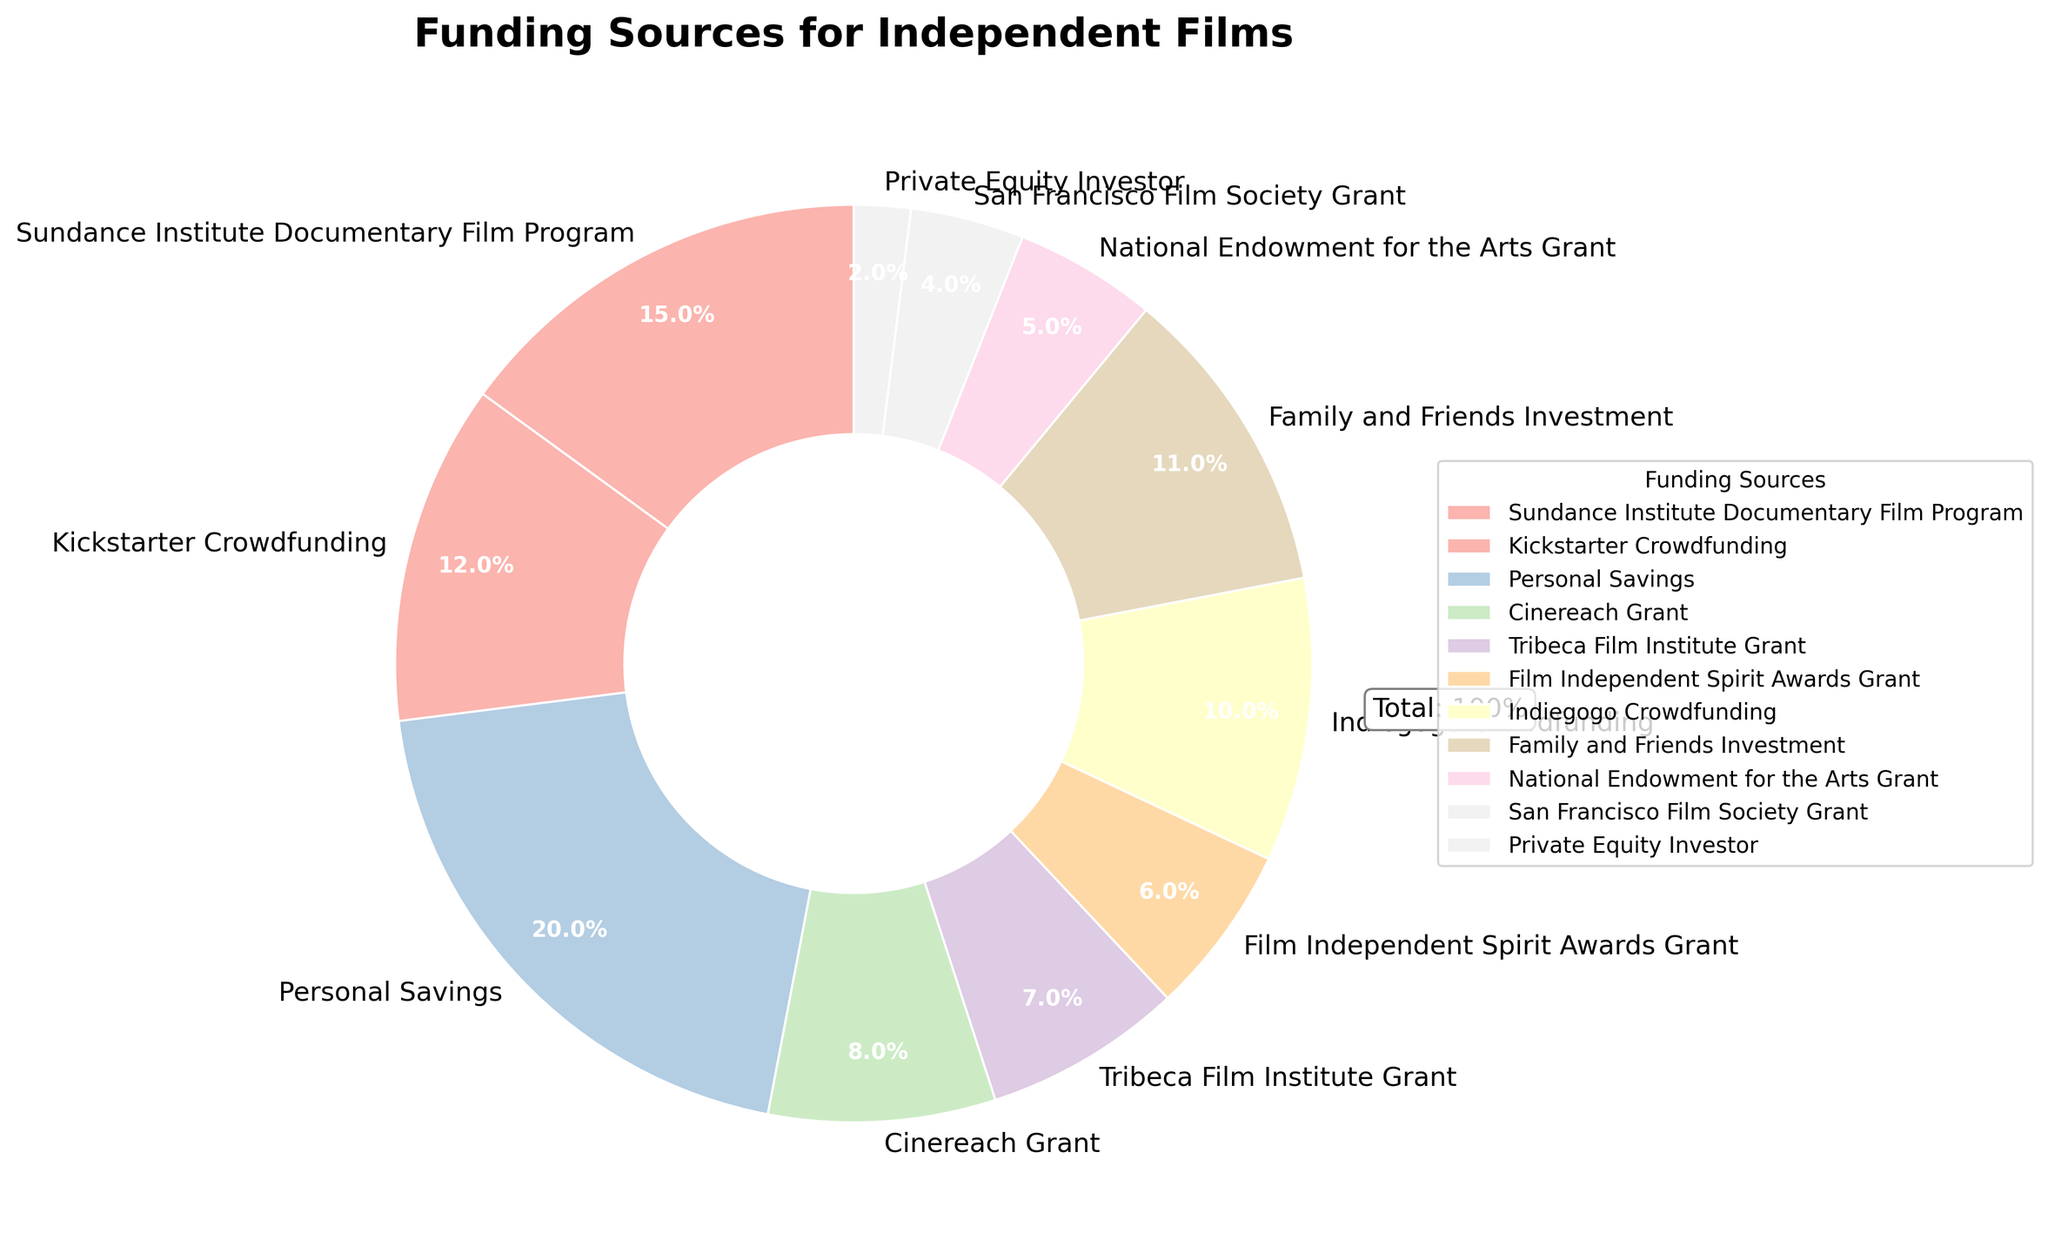Which funding source contributes the most to independent films? Personal Savings contributes 20%, which is the highest among all sources listed.
Answer: Personal Savings Which funding source contributes the second most to independent films? The Sundance Institute Documentary Film Program contributes 15%, second only to Personal Savings.
Answer: Sundance Institute Documentary Film Program How much more do Personal Savings contribute compared to Kickstarter Crowdfunding? Personal Savings contributes 20%, while Kickstarter Crowdfunding contributes 12%. The difference is 20% - 12% = 8%.
Answer: 8% Which two funding sources contribute equally to independent films? Both Indiegogo Crowdfunding and Family and Friends Investment contribute 10% and 11% respectively. There are no exact equal contributions among the sources listed.
Answer: None What is the combined contribution of all grants (not including crowdfunding or personal/family investments)? Summing up the contributions of all grants: Sundance Institute Documentary Film Program (15%), Cinereach Grant (8%), Tribeca Film Institute Grant (7%), Film Independent Spirit Awards Grant (6%), National Endowment for the Arts Grant (5%), San Francisco Film Society Grant (4%) gives 15% + 8% + 7% + 6% + 5% + 4% = 45%.
Answer: 45% Which crowdfunding platform contributes the least? Kickstarter Crowdfunding contributes 12% and Indiegogo Crowdfunding contributes 10%, so the least is Indiegogo Crowdfunding.
Answer: Indiegogo Crowdfunding Is the contribution of Family and Friends Investment greater than that of Private Equity Investor? If so, by how much? Family and Friends Investment contributes 11%, and Private Equity Investor contributes 2%. The difference is 11% - 2% = 9%.
Answer: Yes, by 9% Are there any funding sources that contribute less than 5%? If so, which one? Yes, Private Equity Investor contributes 2% and San Francisco Film Society Grant contributes 4%.
Answer: Private Equity Investor and San Francisco Film Society Grant What is the average contribution of the top three funding sources? The top three funding sources are Personal Savings (20%), Sundance Institute Documentary Film Program (15%), and Kickstarter Crowdfunding (12%). The average is (20% + 15% + 12%) / 3 = 47% / 3 = 15.67%.
Answer: 15.67% What is the percentage difference between the highest and the lowest funding sources? Personal Savings contributes the highest at 20%, and Private Equity Investor contributes the lowest at 2%. The percentage difference is 20% - 2% = 18%.
Answer: 18% 